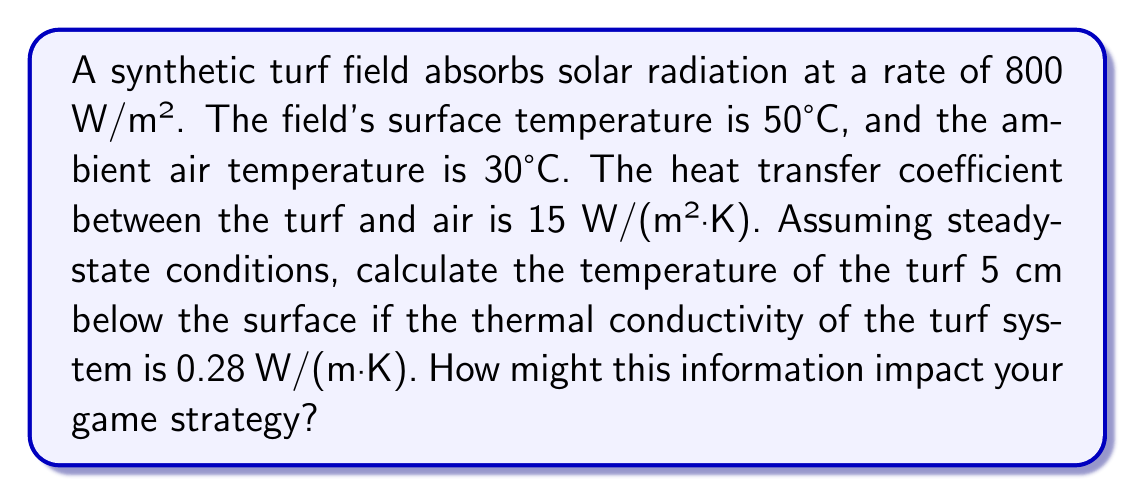Can you answer this question? To solve this problem, we'll use the one-dimensional steady-state heat equation and the concept of thermal resistance. Let's approach this step-by-step:

1) First, we need to determine the heat flux through the turf. In steady-state, the heat absorbed must equal the heat dissipated to the air plus the heat conducted through the turf.

2) Heat dissipated to the air:
   $q_{air} = h(T_s - T_a)$
   Where $h$ is the heat transfer coefficient, $T_s$ is the surface temperature, and $T_a$ is the air temperature.
   $q_{air} = 15 \, \text{W/(m²·K)} \cdot (50°\text{C} - 30°\text{C}) = 300 \, \text{W/m²}$

3) Heat conducted through the turf:
   $q_{cond} = q_{absorbed} - q_{air} = 800 \, \text{W/m²} - 300 \, \text{W/m²} = 500 \, \text{W/m²}$

4) Now we can use Fourier's law of heat conduction:
   $q = -k \frac{dT}{dx}$

   Where $k$ is the thermal conductivity, and $\frac{dT}{dx}$ is the temperature gradient.

5) Rearranging and integrating:
   $\int_{T_s}^{T_5} dT = -\frac{q}{k} \int_0^{0.05} dx$

   $T_5 - T_s = -\frac{q \cdot \Delta x}{k}$

6) Solving for $T_5$:
   $T_5 = T_s - \frac{q \cdot \Delta x}{k}$
   $T_5 = 50°\text{C} - \frac{500 \, \text{W/m²} \cdot 0.05 \, \text{m}}{0.28 \, \text{W/(m·K)}}$
   $T_5 = 50°\text{C} - 89.29°\text{C} = -39.29°\text{C}$

This result indicates that the temperature 5 cm below the surface would be approximately -39.29°C, which is physically impossible in this scenario. This suggests that our steady-state assumption is invalid, and the system is likely in a transient state.

For game strategy, this analysis shows that heat accumulates significantly in the top layer of the turf, which could lead to player discomfort and increased risk of heat-related injuries. Strategies might include more frequent player rotations, increased hydration breaks, and potentially scheduling games during cooler parts of the day.
Answer: Steady-state assumption invalid; system in transient state. Surface heat accumulation significant. 